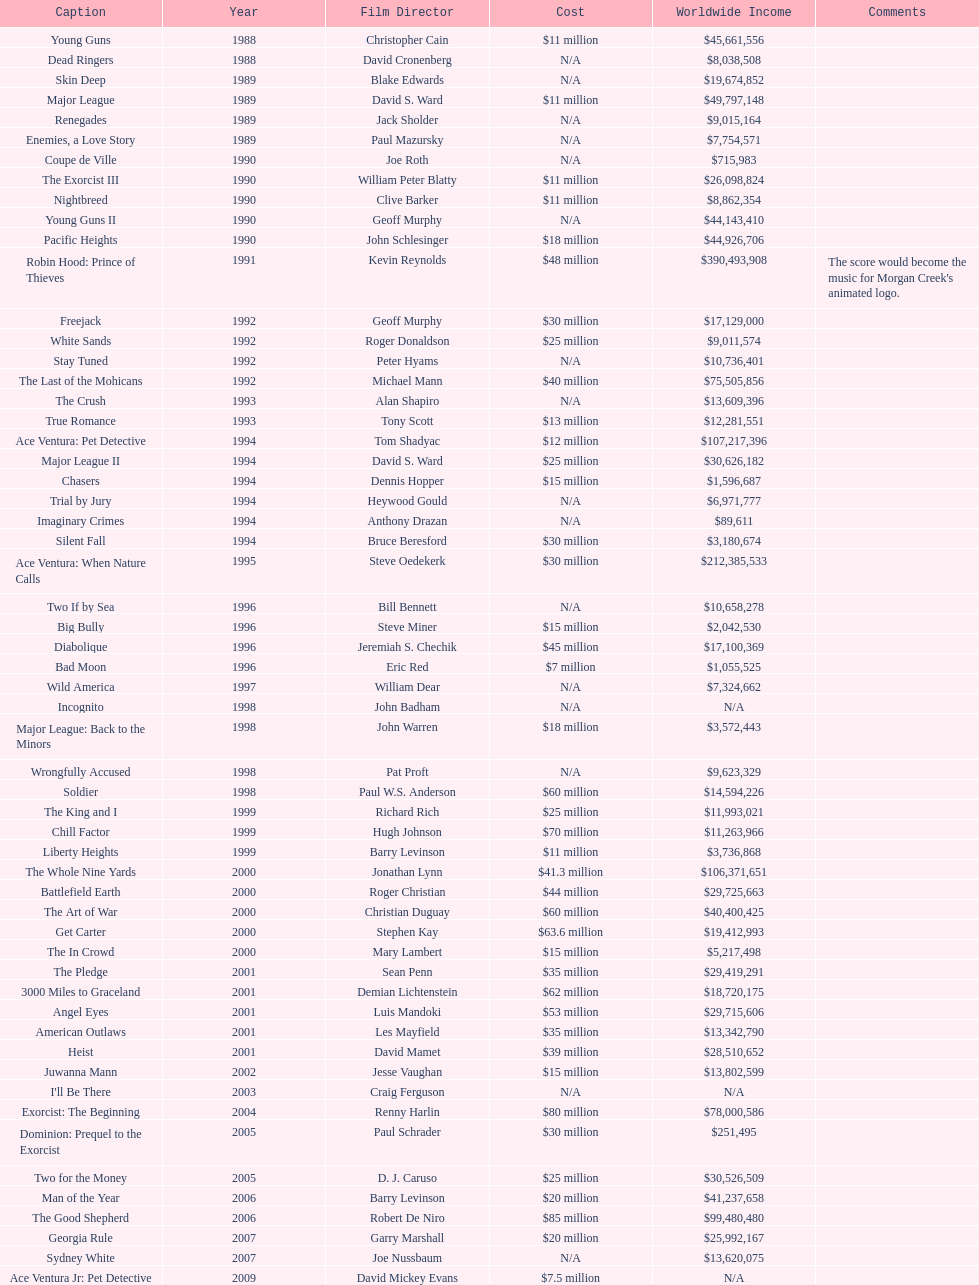Following young guns, which film had the identical budget? Major League. 